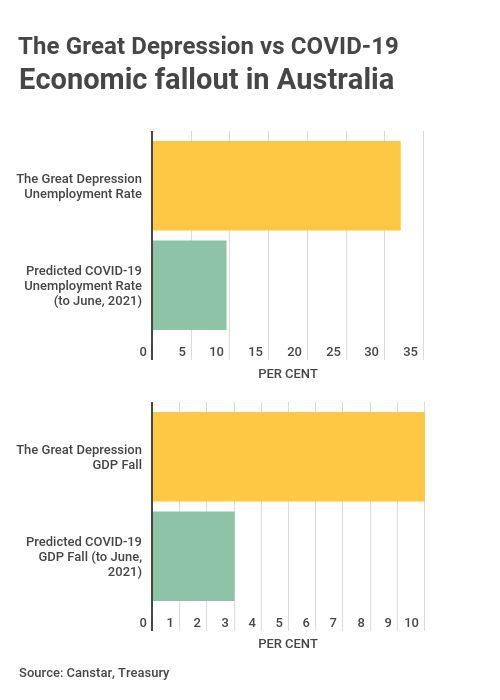Indicate a few pertinent items in this graphic. The color that represents the impact due to COVID is green. The predicted fall in GDP due to COVID-19 is expected to be 3%. The color yellow is associated with the impact of the Great Depression. During the Great Depression, the GDP experienced a significant fall of 10%. 